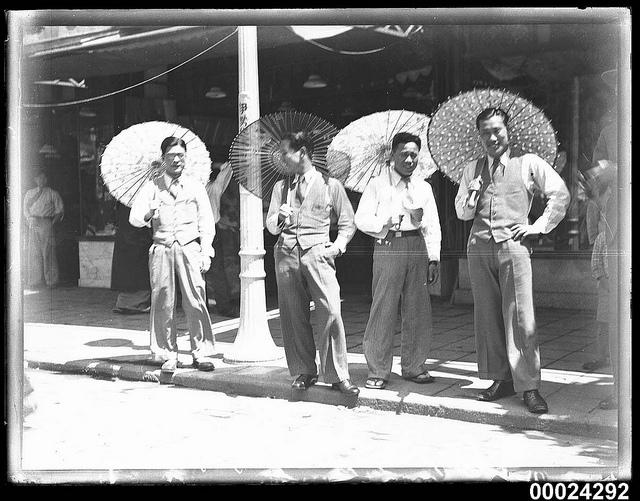What are the men holding?
Concise answer only. Umbrellas. Is the photo in color or black and white?
Short answer required. Black and white. How many parasols are in this photo?
Keep it brief. 4. 